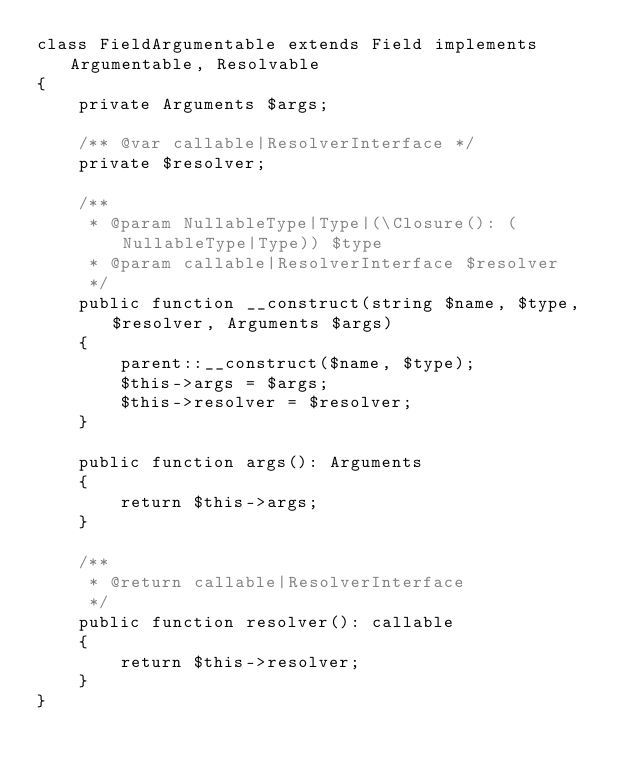<code> <loc_0><loc_0><loc_500><loc_500><_PHP_>class FieldArgumentable extends Field implements Argumentable, Resolvable
{
    private Arguments $args;

    /** @var callable|ResolverInterface */
    private $resolver;

    /**
     * @param NullableType|Type|(\Closure(): (NullableType|Type)) $type
     * @param callable|ResolverInterface $resolver
     */
    public function __construct(string $name, $type, $resolver, Arguments $args)
    {
        parent::__construct($name, $type);
        $this->args = $args;
        $this->resolver = $resolver;
    }

    public function args(): Arguments
    {
        return $this->args;
    }

    /**
     * @return callable|ResolverInterface
     */
    public function resolver(): callable
    {
        return $this->resolver;
    }
}
</code> 